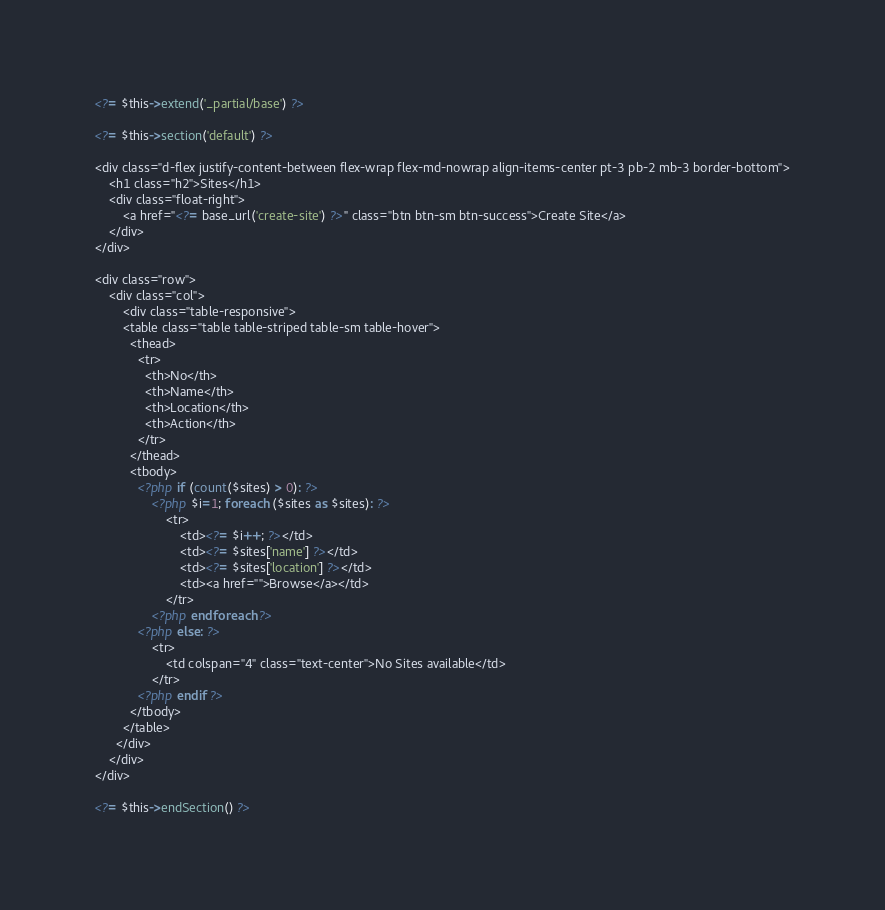<code> <loc_0><loc_0><loc_500><loc_500><_PHP_><?= $this->extend('_partial/base') ?>

<?= $this->section('default') ?>

<div class="d-flex justify-content-between flex-wrap flex-md-nowrap align-items-center pt-3 pb-2 mb-3 border-bottom">
	<h1 class="h2">Sites</h1>
	<div class="float-right">
		<a href="<?= base_url('create-site') ?>" class="btn btn-sm btn-success">Create Site</a>
	</div>
</div>

<div class="row">
	<div class="col">
		<div class="table-responsive">
	    <table class="table table-striped table-sm table-hover">
	      <thead>
	        <tr>
	          <th>No</th>
	          <th>Name</th>
	          <th>Location</th>
	          <th>Action</th>
	        </tr>
	      </thead>
	      <tbody>
	      	<?php if (count($sites) > 0): ?>
	      		<?php $i=1; foreach ($sites as $sites): ?>
		      		<tr>
		      			<td><?= $i++; ?></td>
		      			<td><?= $sites['name'] ?></td>
		      			<td><?= $sites['location'] ?></td>
		      			<td><a href="">Browse</a></td>
		      		</tr>
		      	<?php endforeach ?>
	      	<?php else: ?>
	      		<tr>
	      			<td colspan="4" class="text-center">No Sites available</td>
	      		</tr>
	      	<?php endif ?>
	      </tbody>
	    </table>
	  </div>
	</div>
</div>

<?= $this->endSection() ?></code> 